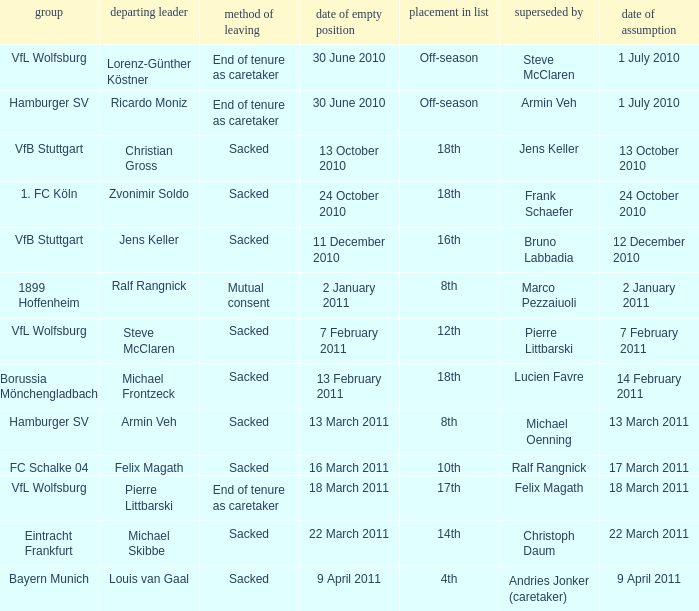When 1. fc köln is the team what is the date of appointment? 24 October 2010. 